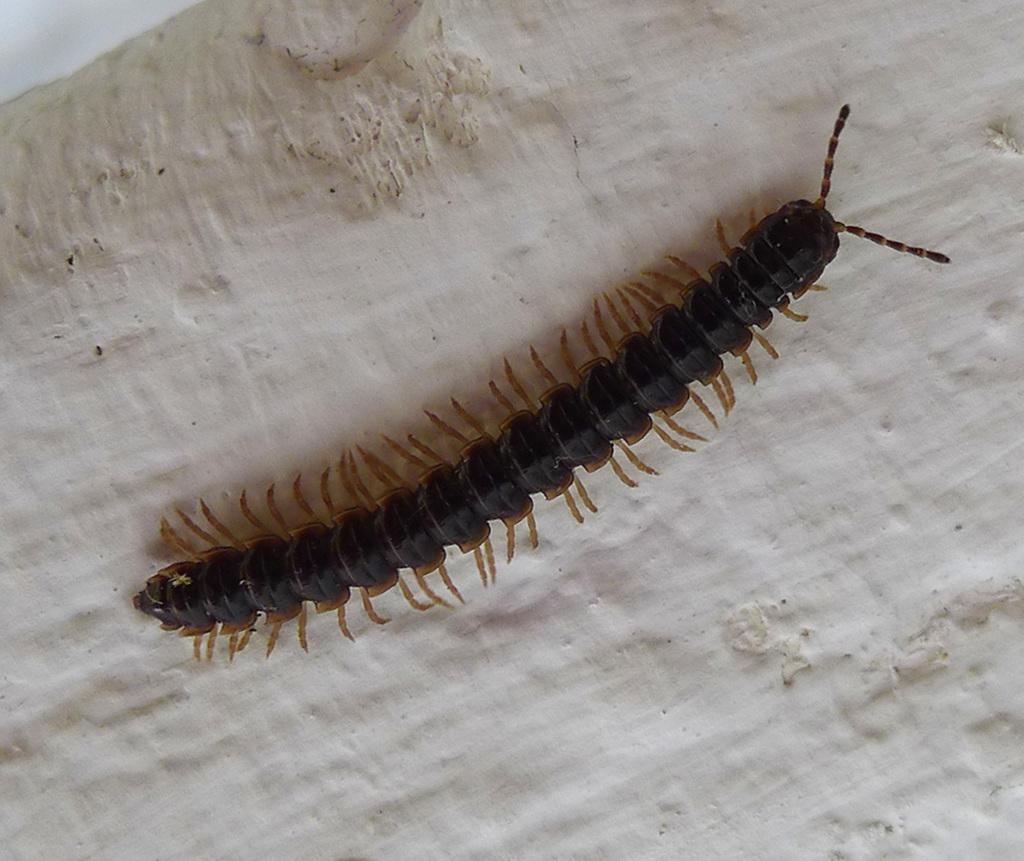What type of creature is present in the image? There is an insect in the image. What colors can be seen on the insect? The insect has black and brown coloration. What is the background or surface that the insect is on? The insect is on a cream-colored surface. What grade does the goose receive in the image? There is no goose present in the image, so it is not possible to determine a grade for it. 